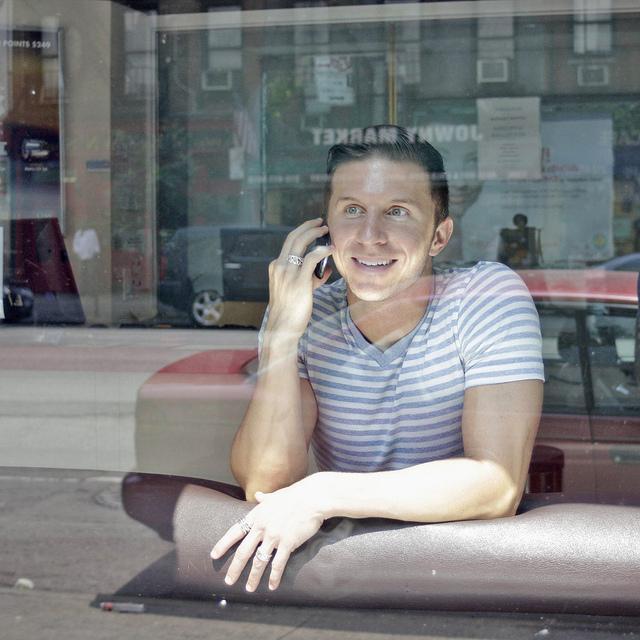What is the man on the phone sitting behind?
Answer the question by selecting the correct answer among the 4 following choices.
Options: Plastic, glass, foil, paper. Glass. 